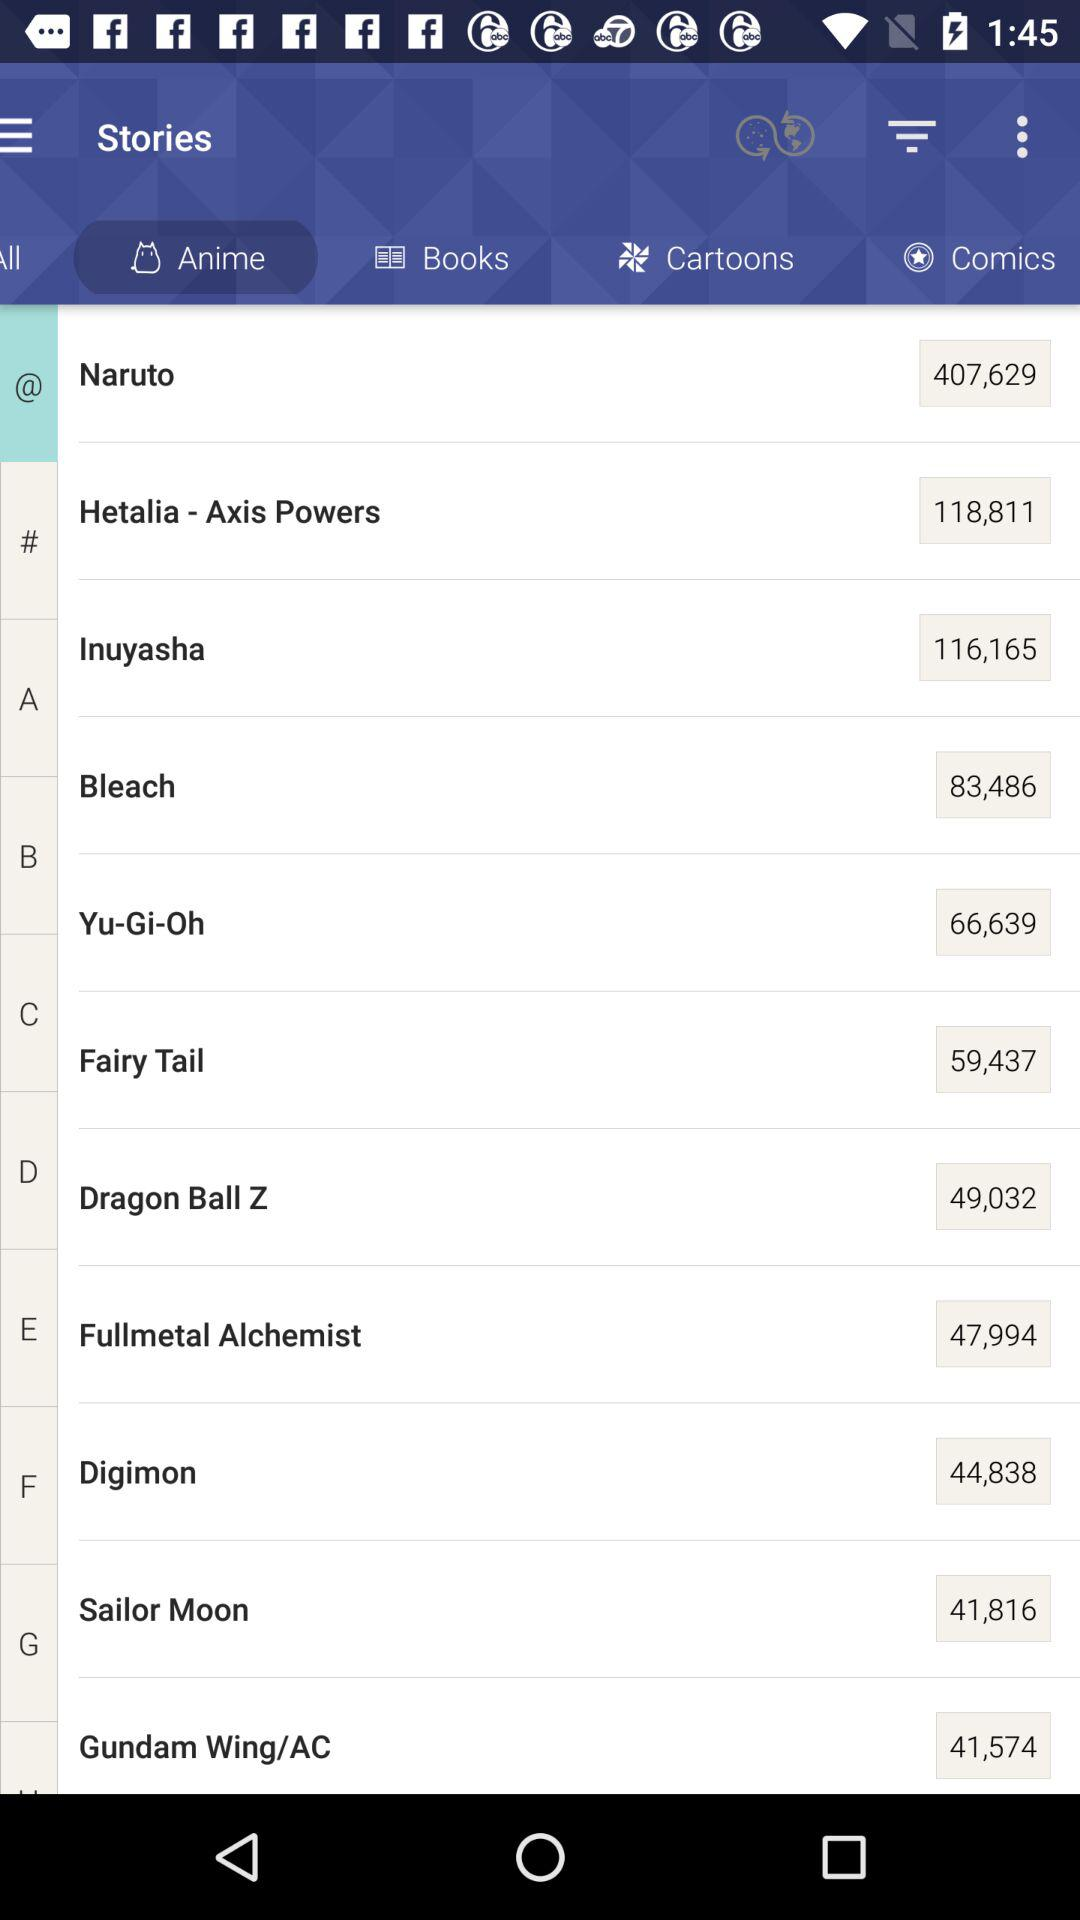What is the number in Naruto? The number in Naruto is 407,629. 